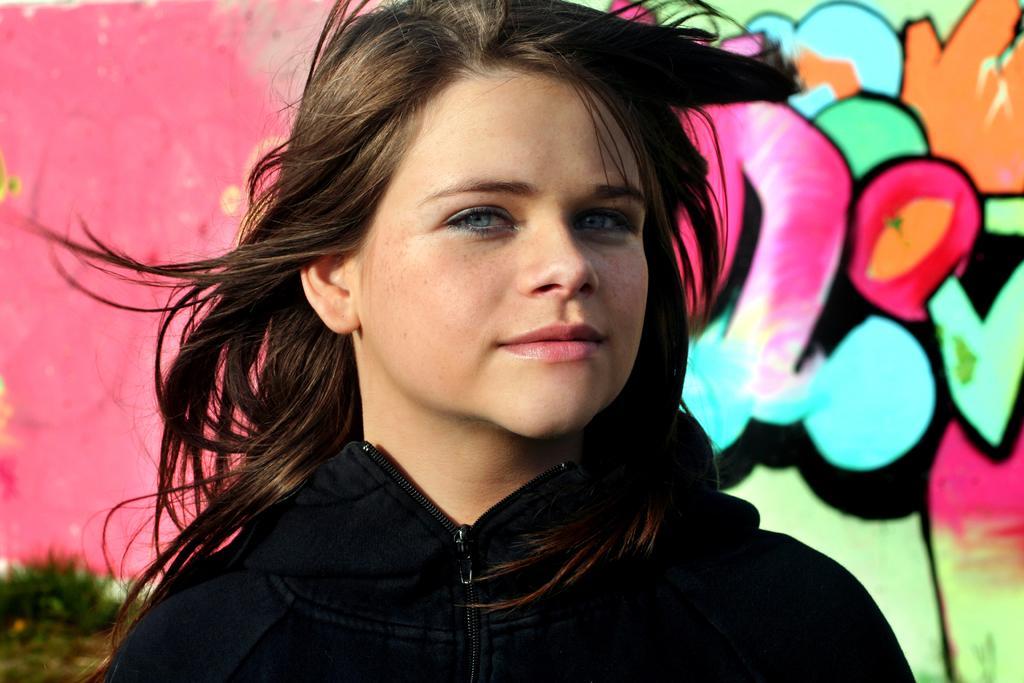Can you describe this image briefly? In this picture there is a girl in the center of the image and there is graffiti in the background area of the image. 